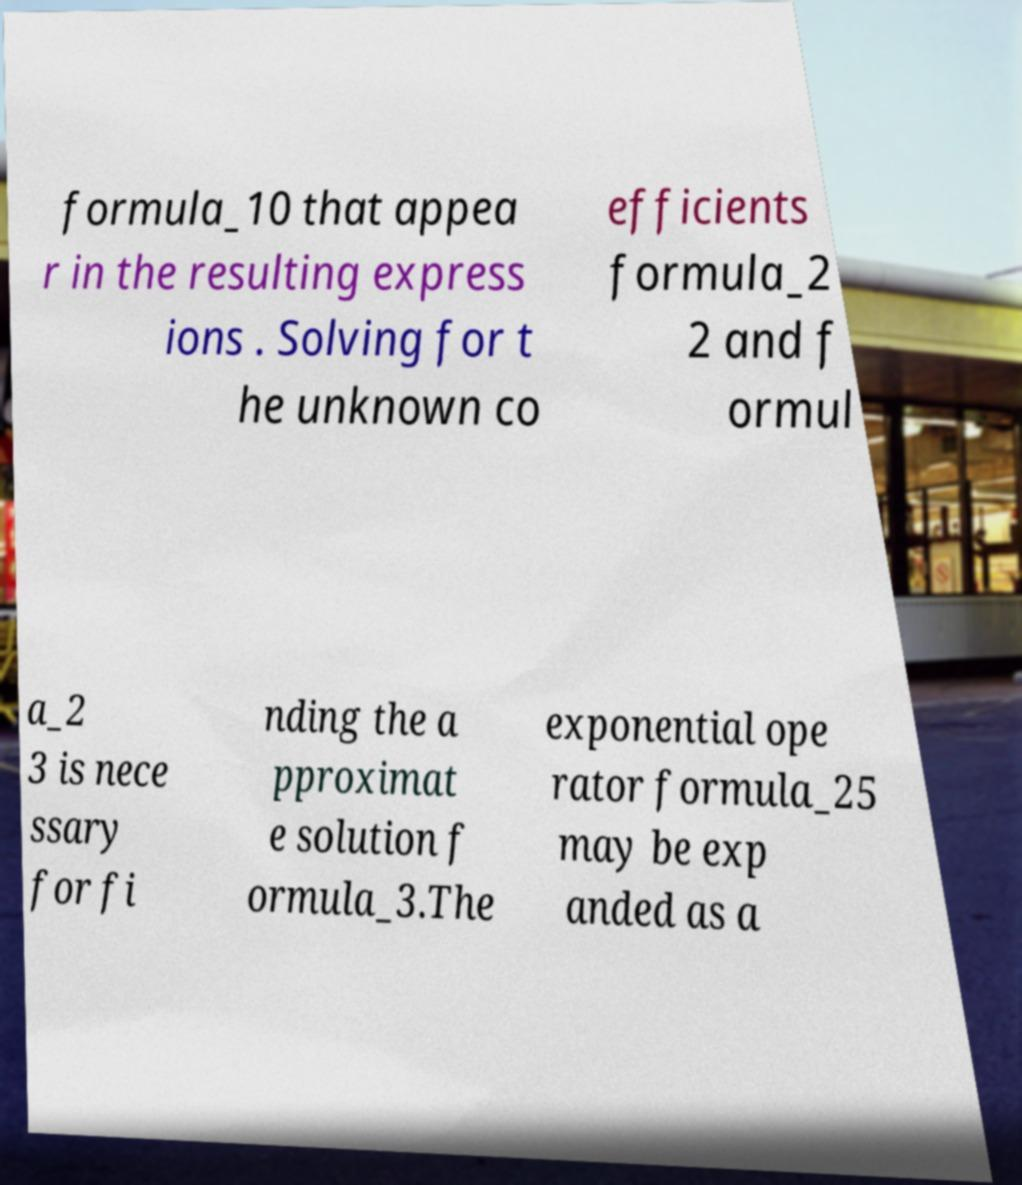Please read and relay the text visible in this image. What does it say? formula_10 that appea r in the resulting express ions . Solving for t he unknown co efficients formula_2 2 and f ormul a_2 3 is nece ssary for fi nding the a pproximat e solution f ormula_3.The exponential ope rator formula_25 may be exp anded as a 